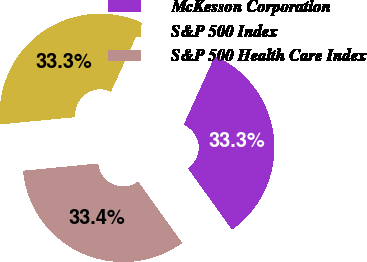<chart> <loc_0><loc_0><loc_500><loc_500><pie_chart><fcel>McKesson Corporation<fcel>S&P 500 Index<fcel>S&P 500 Health Care Index<nl><fcel>33.3%<fcel>33.33%<fcel>33.37%<nl></chart> 